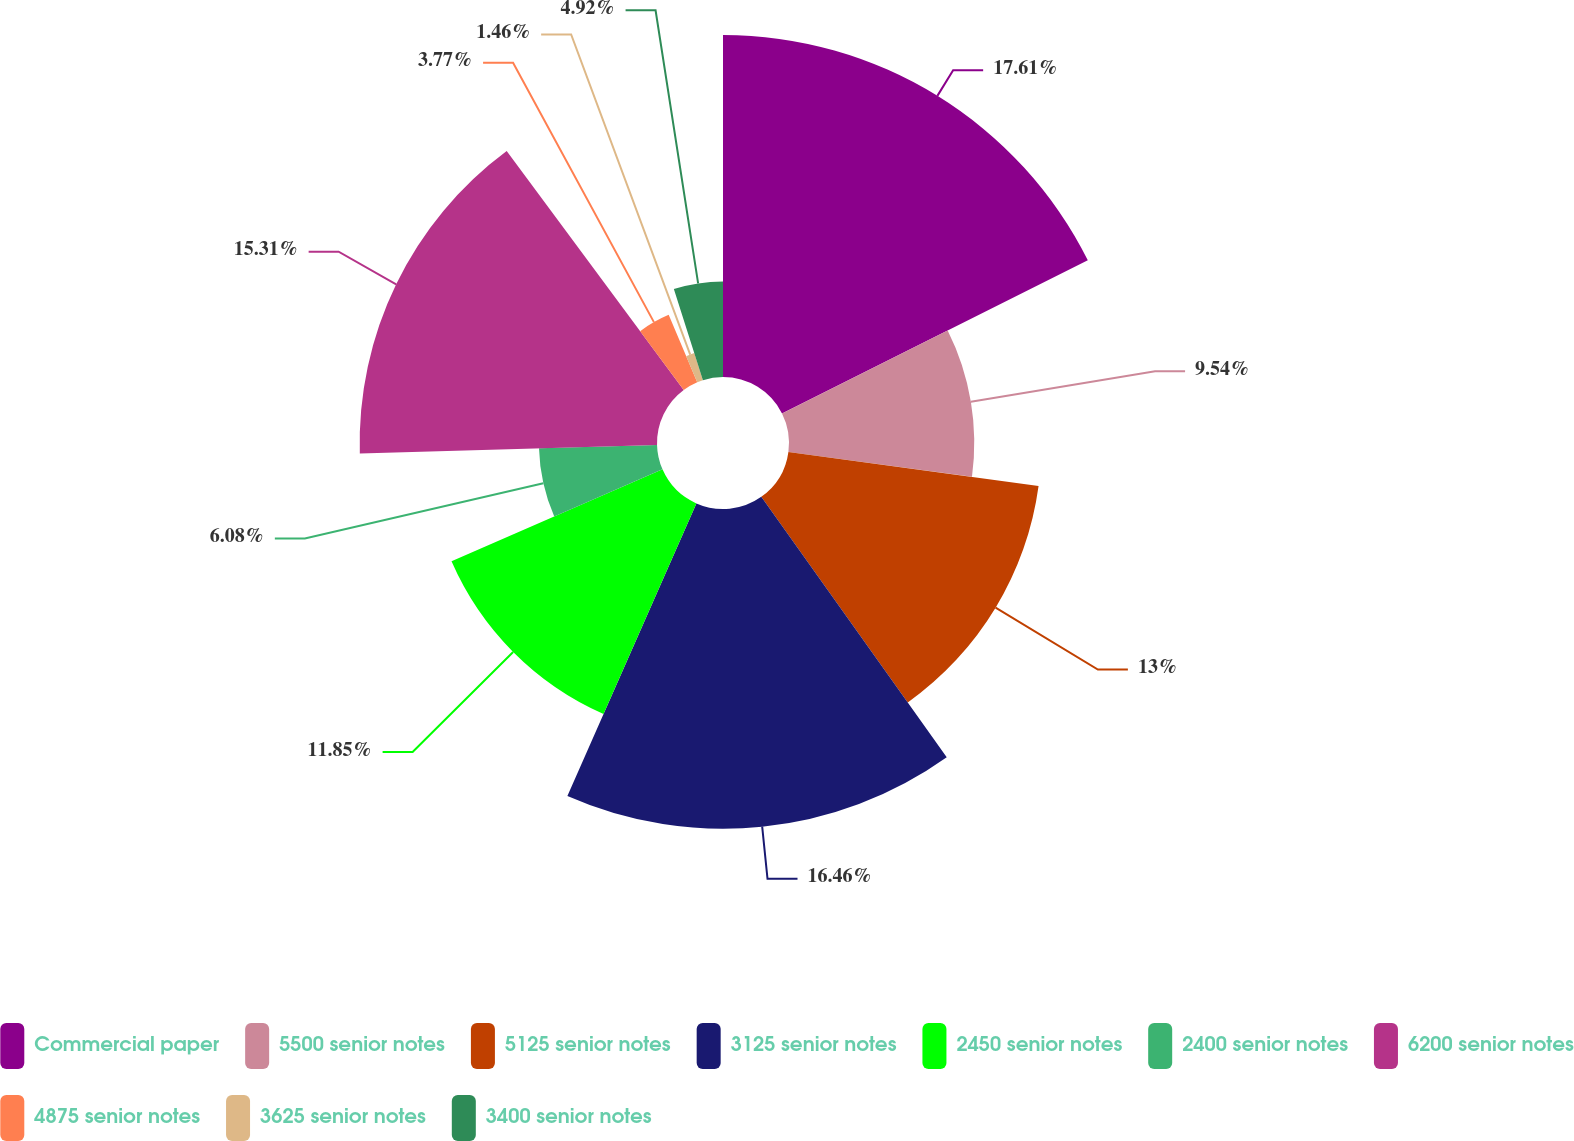Convert chart to OTSL. <chart><loc_0><loc_0><loc_500><loc_500><pie_chart><fcel>Commercial paper<fcel>5500 senior notes<fcel>5125 senior notes<fcel>3125 senior notes<fcel>2450 senior notes<fcel>2400 senior notes<fcel>6200 senior notes<fcel>4875 senior notes<fcel>3625 senior notes<fcel>3400 senior notes<nl><fcel>17.61%<fcel>9.54%<fcel>13.0%<fcel>16.46%<fcel>11.85%<fcel>6.08%<fcel>15.31%<fcel>3.77%<fcel>1.46%<fcel>4.92%<nl></chart> 